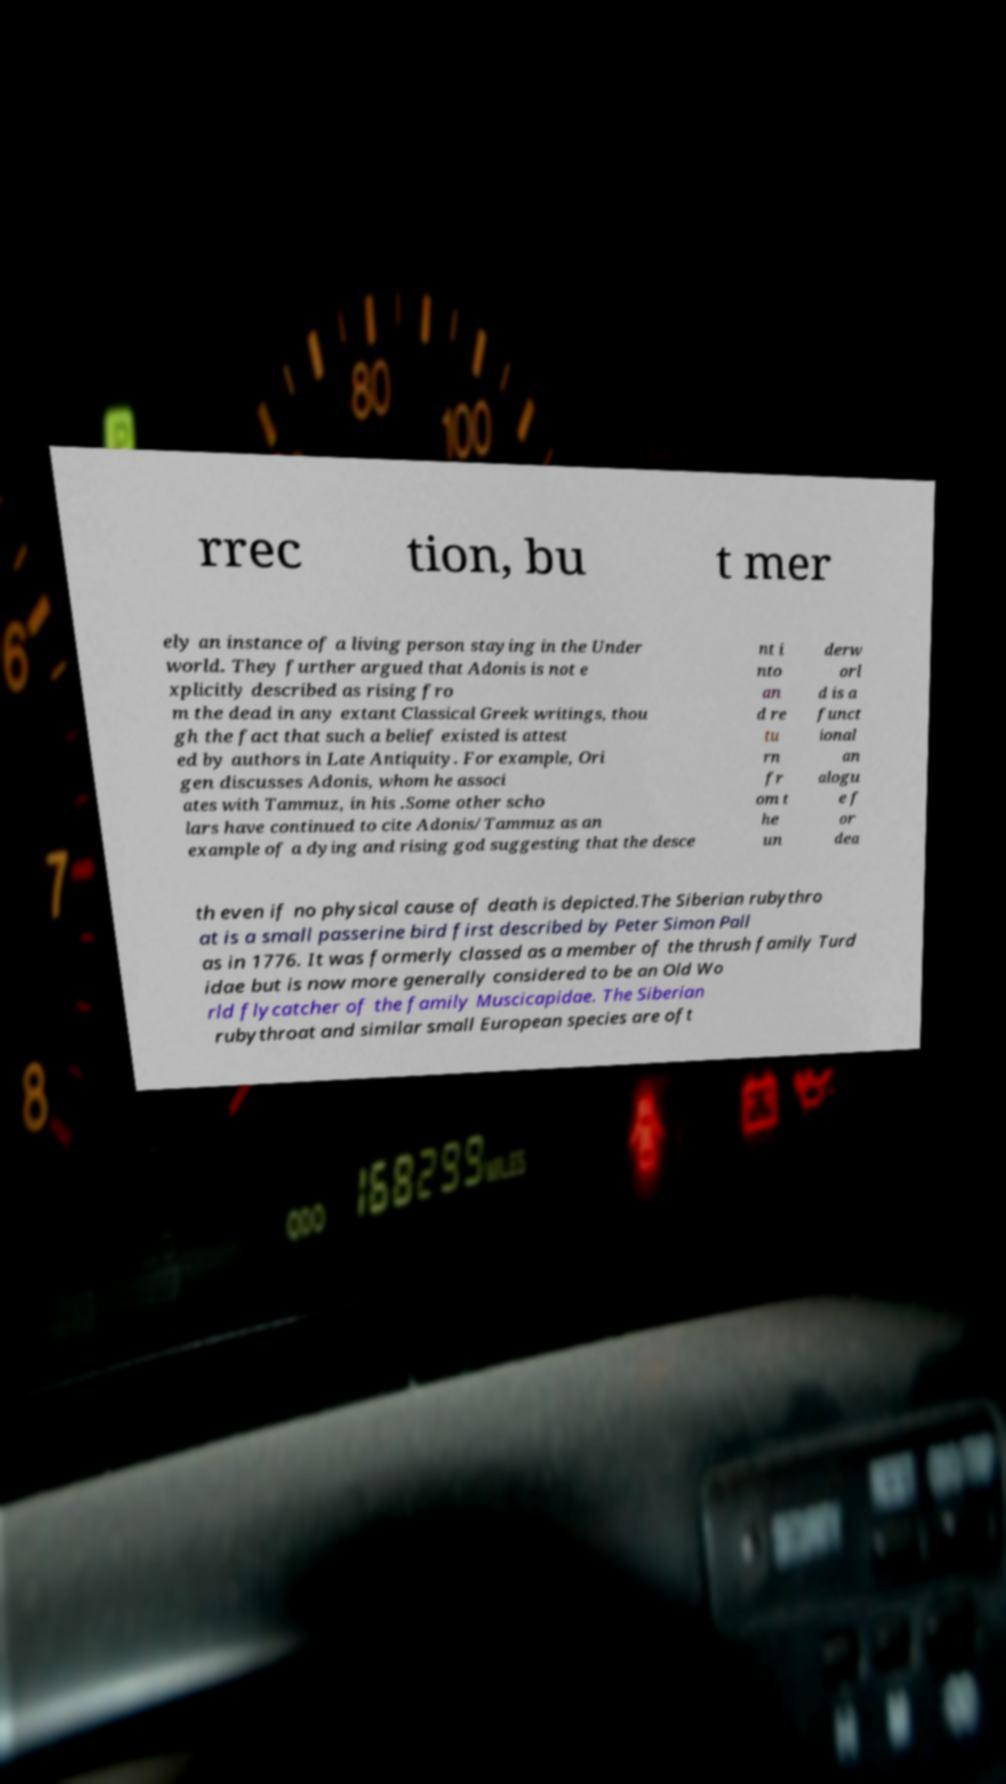Please read and relay the text visible in this image. What does it say? rrec tion, bu t mer ely an instance of a living person staying in the Under world. They further argued that Adonis is not e xplicitly described as rising fro m the dead in any extant Classical Greek writings, thou gh the fact that such a belief existed is attest ed by authors in Late Antiquity. For example, Ori gen discusses Adonis, whom he associ ates with Tammuz, in his .Some other scho lars have continued to cite Adonis/Tammuz as an example of a dying and rising god suggesting that the desce nt i nto an d re tu rn fr om t he un derw orl d is a funct ional an alogu e f or dea th even if no physical cause of death is depicted.The Siberian rubythro at is a small passerine bird first described by Peter Simon Pall as in 1776. It was formerly classed as a member of the thrush family Turd idae but is now more generally considered to be an Old Wo rld flycatcher of the family Muscicapidae. The Siberian rubythroat and similar small European species are oft 